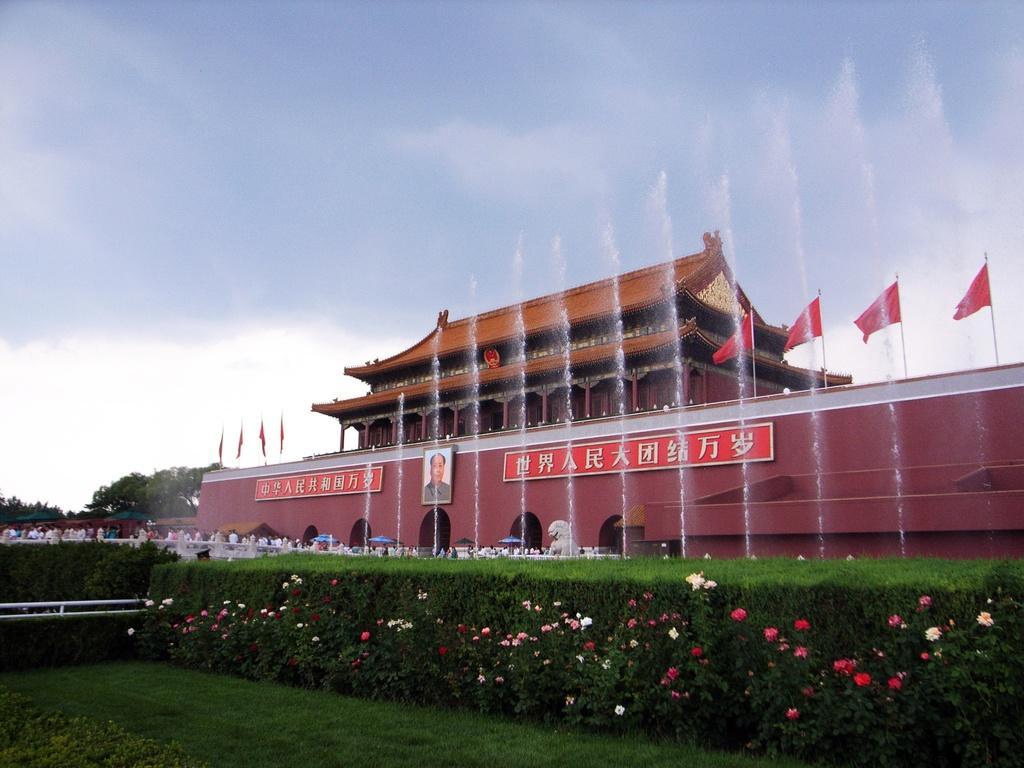Can you describe this image briefly? In this image, at the bottom there are plants, flowers, grass. In the middle there are people, flags, water fountains, building, trees, photo frame, boards, text, sky and clouds. 